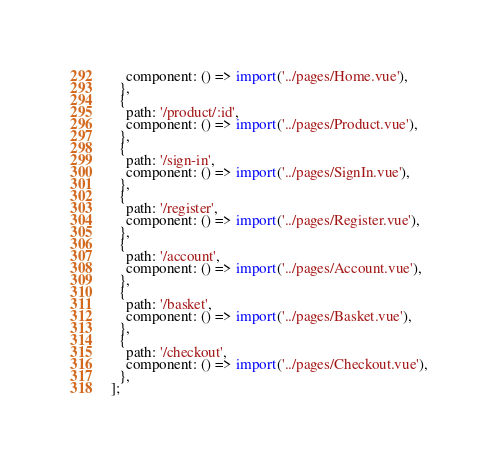<code> <loc_0><loc_0><loc_500><loc_500><_JavaScript_>    component: () => import('../pages/Home.vue'),
  },
  {
    path: '/product/:id',
    component: () => import('../pages/Product.vue'),
  },
  {
    path: '/sign-in',
    component: () => import('../pages/SignIn.vue'),
  },
  {
    path: '/register',
    component: () => import('../pages/Register.vue'),
  },
  {
    path: '/account',
    component: () => import('../pages/Account.vue'),
  },
  {
    path: '/basket',
    component: () => import('../pages/Basket.vue'),
  },
  {
    path: '/checkout',
    component: () => import('../pages/Checkout.vue'),
  },
];</code> 